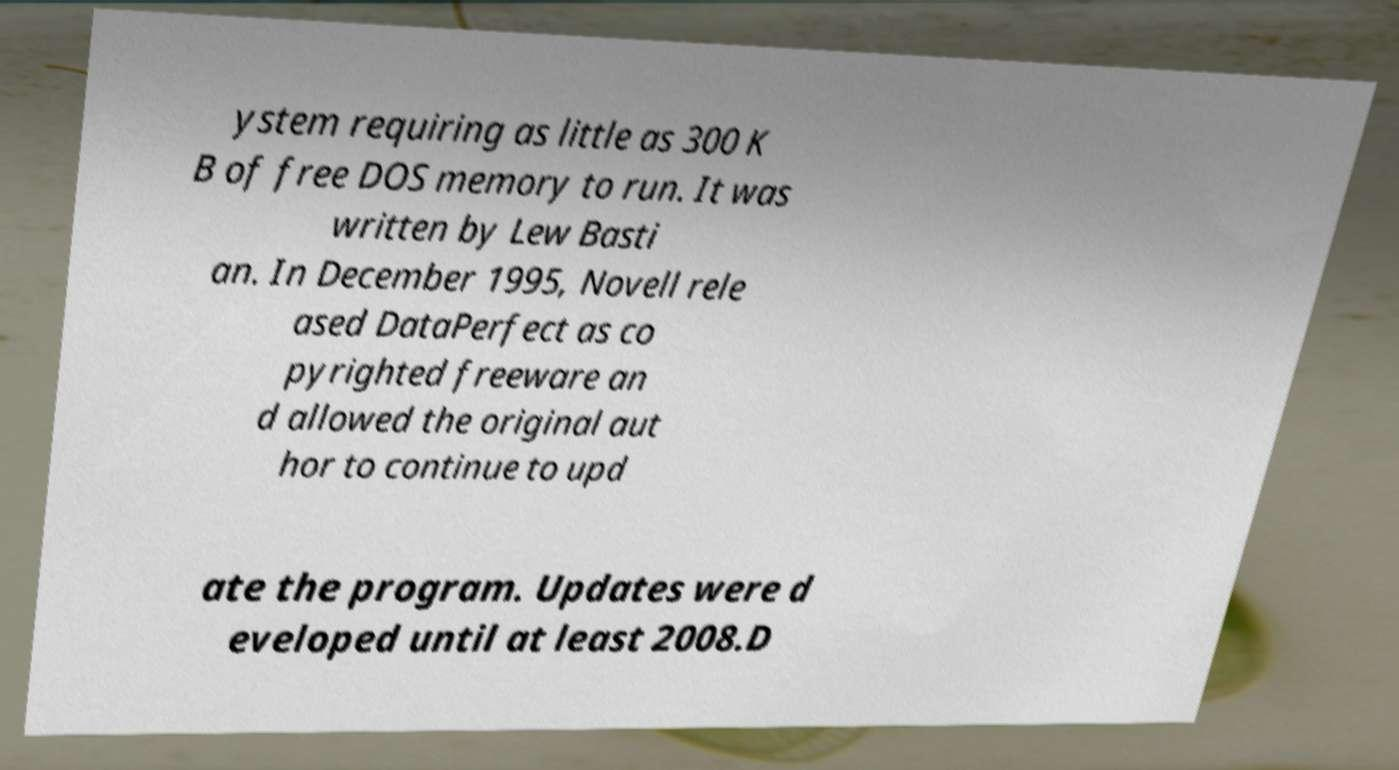What messages or text are displayed in this image? I need them in a readable, typed format. ystem requiring as little as 300 K B of free DOS memory to run. It was written by Lew Basti an. In December 1995, Novell rele ased DataPerfect as co pyrighted freeware an d allowed the original aut hor to continue to upd ate the program. Updates were d eveloped until at least 2008.D 